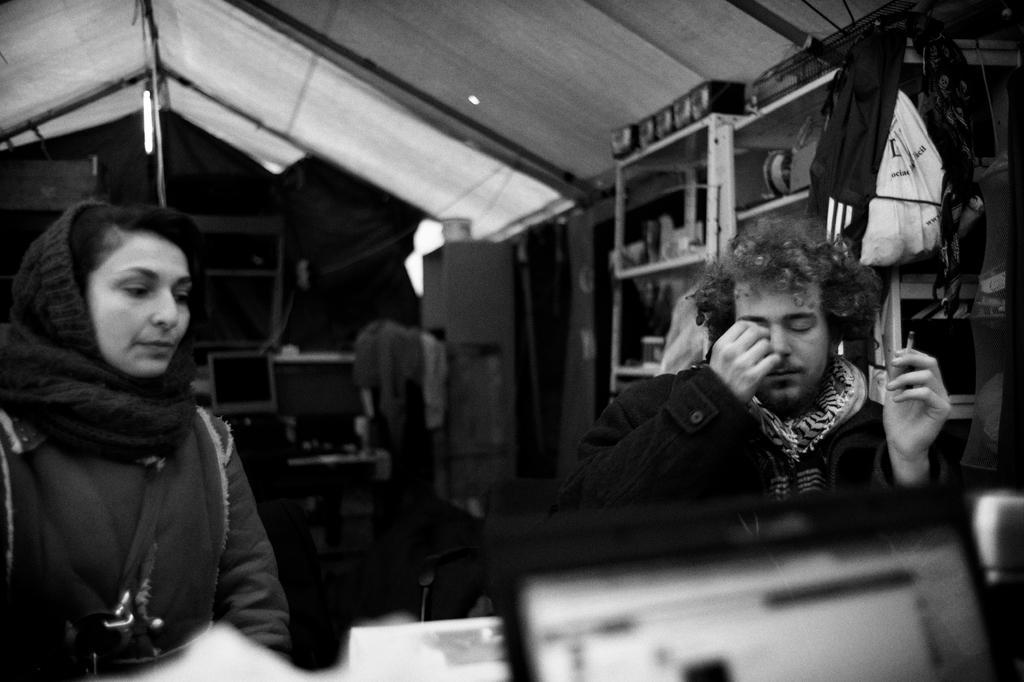In one or two sentences, can you explain what this image depicts? This is a black and white image. In the center of the image there are two persons. At the top of the image there is a cloth. In the background of the image there is a monitor. There is a chair. To the right side of the image there is a shelf. 